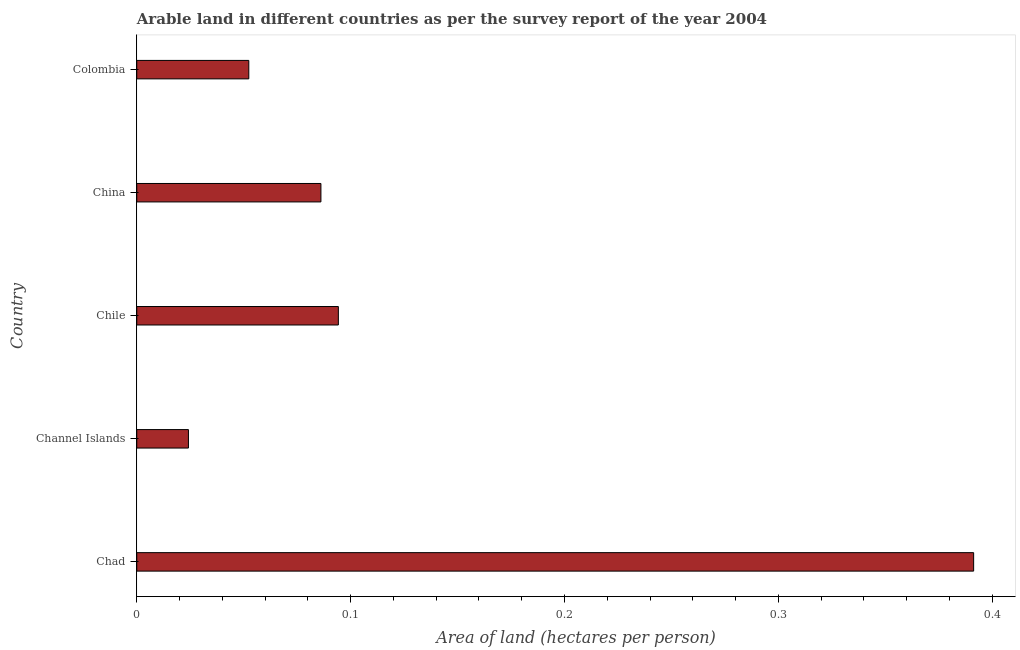What is the title of the graph?
Provide a short and direct response. Arable land in different countries as per the survey report of the year 2004. What is the label or title of the X-axis?
Give a very brief answer. Area of land (hectares per person). What is the label or title of the Y-axis?
Provide a short and direct response. Country. What is the area of arable land in Chile?
Your answer should be compact. 0.09. Across all countries, what is the maximum area of arable land?
Keep it short and to the point. 0.39. Across all countries, what is the minimum area of arable land?
Your answer should be very brief. 0.02. In which country was the area of arable land maximum?
Your response must be concise. Chad. In which country was the area of arable land minimum?
Provide a succinct answer. Channel Islands. What is the sum of the area of arable land?
Make the answer very short. 0.65. What is the difference between the area of arable land in Chad and China?
Ensure brevity in your answer.  0.3. What is the average area of arable land per country?
Give a very brief answer. 0.13. What is the median area of arable land?
Your answer should be compact. 0.09. In how many countries, is the area of arable land greater than 0.16 hectares per person?
Keep it short and to the point. 1. What is the ratio of the area of arable land in Channel Islands to that in China?
Provide a short and direct response. 0.28. What is the difference between the highest and the second highest area of arable land?
Make the answer very short. 0.3. What is the difference between the highest and the lowest area of arable land?
Make the answer very short. 0.37. Are all the bars in the graph horizontal?
Your response must be concise. Yes. What is the difference between two consecutive major ticks on the X-axis?
Provide a short and direct response. 0.1. Are the values on the major ticks of X-axis written in scientific E-notation?
Make the answer very short. No. What is the Area of land (hectares per person) in Chad?
Ensure brevity in your answer.  0.39. What is the Area of land (hectares per person) in Channel Islands?
Give a very brief answer. 0.02. What is the Area of land (hectares per person) of Chile?
Your response must be concise. 0.09. What is the Area of land (hectares per person) in China?
Give a very brief answer. 0.09. What is the Area of land (hectares per person) in Colombia?
Make the answer very short. 0.05. What is the difference between the Area of land (hectares per person) in Chad and Channel Islands?
Provide a succinct answer. 0.37. What is the difference between the Area of land (hectares per person) in Chad and Chile?
Offer a terse response. 0.3. What is the difference between the Area of land (hectares per person) in Chad and China?
Offer a very short reply. 0.31. What is the difference between the Area of land (hectares per person) in Chad and Colombia?
Keep it short and to the point. 0.34. What is the difference between the Area of land (hectares per person) in Channel Islands and Chile?
Your answer should be very brief. -0.07. What is the difference between the Area of land (hectares per person) in Channel Islands and China?
Offer a terse response. -0.06. What is the difference between the Area of land (hectares per person) in Channel Islands and Colombia?
Your answer should be compact. -0.03. What is the difference between the Area of land (hectares per person) in Chile and China?
Your answer should be compact. 0.01. What is the difference between the Area of land (hectares per person) in Chile and Colombia?
Offer a very short reply. 0.04. What is the difference between the Area of land (hectares per person) in China and Colombia?
Offer a terse response. 0.03. What is the ratio of the Area of land (hectares per person) in Chad to that in Chile?
Your answer should be compact. 4.15. What is the ratio of the Area of land (hectares per person) in Chad to that in China?
Offer a very short reply. 4.54. What is the ratio of the Area of land (hectares per person) in Chad to that in Colombia?
Provide a succinct answer. 7.47. What is the ratio of the Area of land (hectares per person) in Channel Islands to that in Chile?
Keep it short and to the point. 0.26. What is the ratio of the Area of land (hectares per person) in Channel Islands to that in China?
Your answer should be compact. 0.28. What is the ratio of the Area of land (hectares per person) in Channel Islands to that in Colombia?
Your answer should be compact. 0.46. What is the ratio of the Area of land (hectares per person) in Chile to that in China?
Keep it short and to the point. 1.09. What is the ratio of the Area of land (hectares per person) in Chile to that in Colombia?
Ensure brevity in your answer.  1.8. What is the ratio of the Area of land (hectares per person) in China to that in Colombia?
Provide a short and direct response. 1.64. 